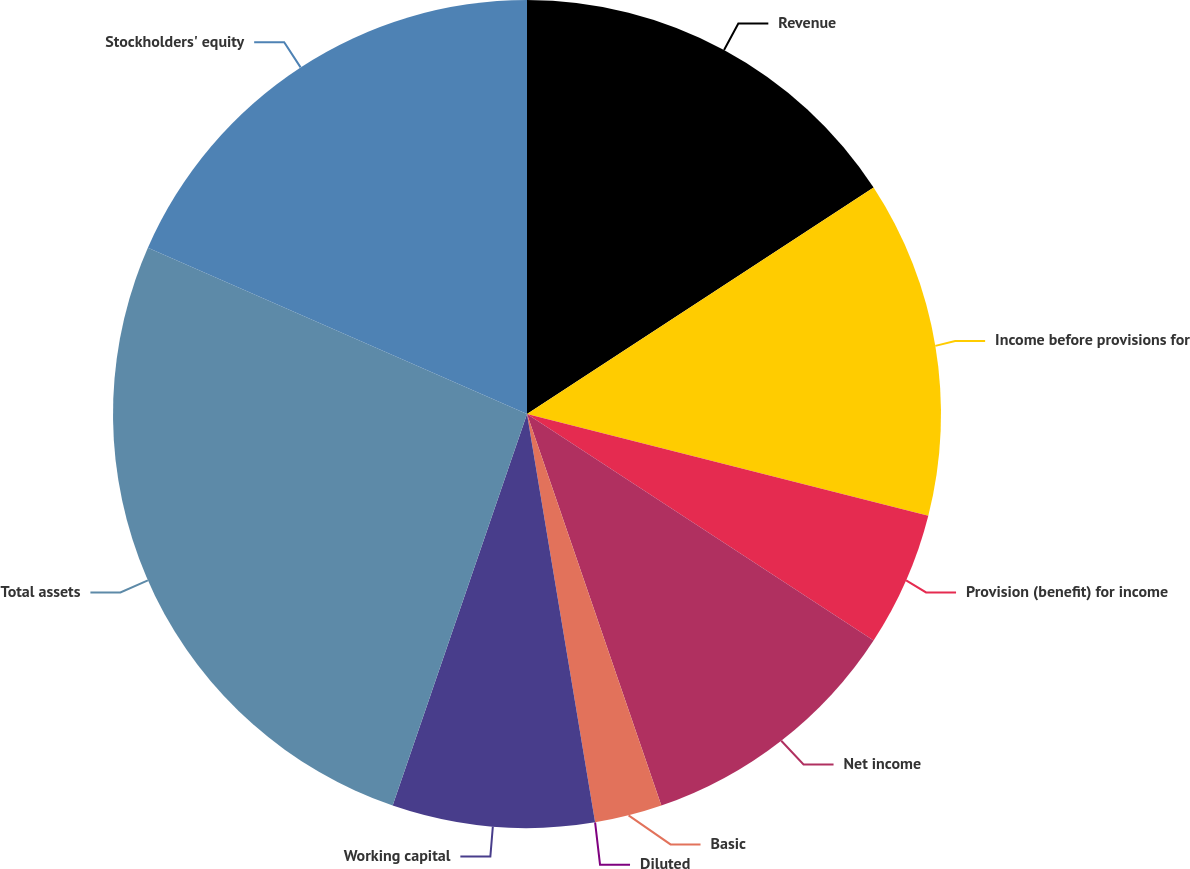Convert chart. <chart><loc_0><loc_0><loc_500><loc_500><pie_chart><fcel>Revenue<fcel>Income before provisions for<fcel>Provision (benefit) for income<fcel>Net income<fcel>Basic<fcel>Diluted<fcel>Working capital<fcel>Total assets<fcel>Stockholders' equity<nl><fcel>15.79%<fcel>13.16%<fcel>5.26%<fcel>10.53%<fcel>2.63%<fcel>0.0%<fcel>7.89%<fcel>26.32%<fcel>18.42%<nl></chart> 